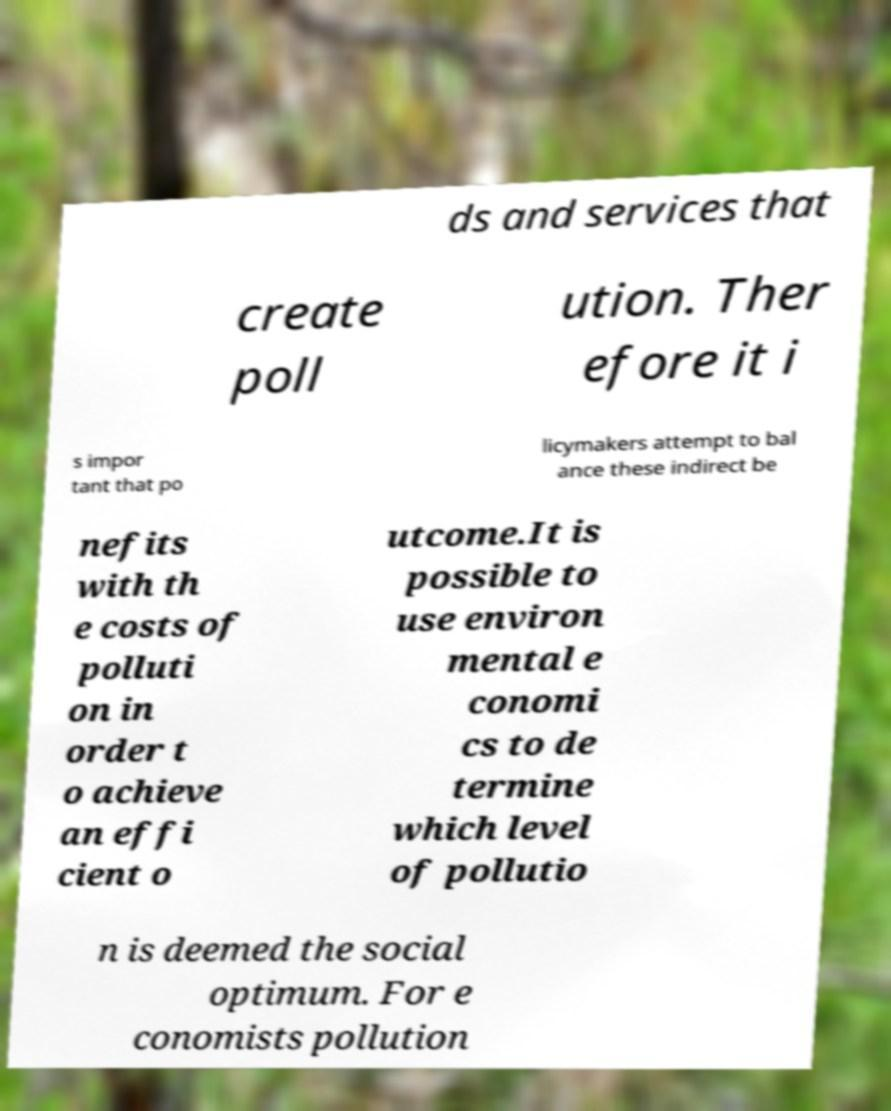I need the written content from this picture converted into text. Can you do that? ds and services that create poll ution. Ther efore it i s impor tant that po licymakers attempt to bal ance these indirect be nefits with th e costs of polluti on in order t o achieve an effi cient o utcome.It is possible to use environ mental e conomi cs to de termine which level of pollutio n is deemed the social optimum. For e conomists pollution 